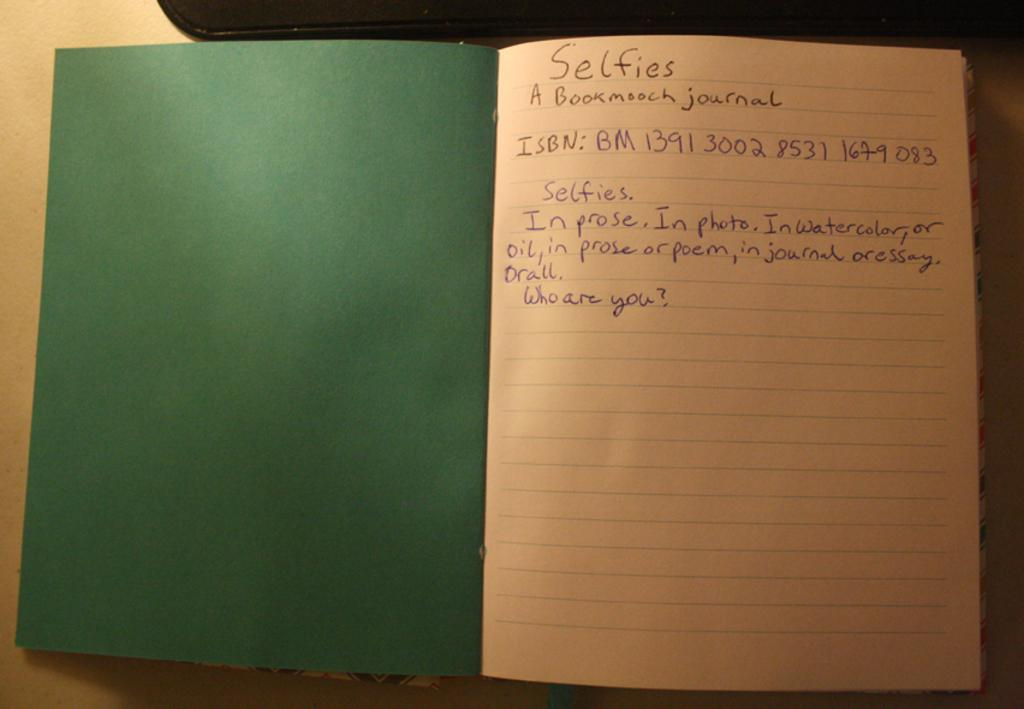<image>
Share a concise interpretation of the image provided. A notebook that has a green cover and on the first page is information on selfies. 